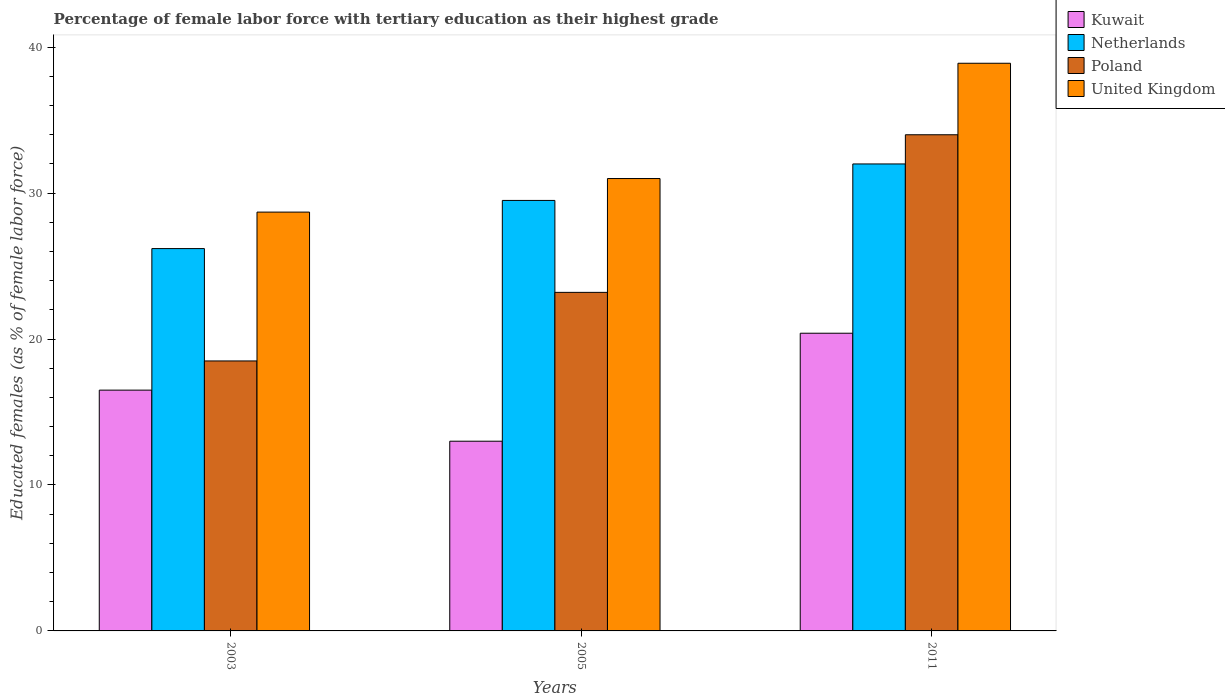How many different coloured bars are there?
Ensure brevity in your answer.  4. How many groups of bars are there?
Provide a short and direct response. 3. Are the number of bars on each tick of the X-axis equal?
Provide a short and direct response. Yes. What is the label of the 1st group of bars from the left?
Keep it short and to the point. 2003. Across all years, what is the maximum percentage of female labor force with tertiary education in United Kingdom?
Make the answer very short. 38.9. Across all years, what is the minimum percentage of female labor force with tertiary education in Netherlands?
Give a very brief answer. 26.2. In which year was the percentage of female labor force with tertiary education in United Kingdom maximum?
Make the answer very short. 2011. In which year was the percentage of female labor force with tertiary education in Poland minimum?
Provide a succinct answer. 2003. What is the total percentage of female labor force with tertiary education in United Kingdom in the graph?
Your response must be concise. 98.6. What is the difference between the percentage of female labor force with tertiary education in United Kingdom in 2003 and that in 2005?
Ensure brevity in your answer.  -2.3. What is the difference between the percentage of female labor force with tertiary education in United Kingdom in 2011 and the percentage of female labor force with tertiary education in Poland in 2005?
Your response must be concise. 15.7. What is the average percentage of female labor force with tertiary education in Netherlands per year?
Your response must be concise. 29.23. In the year 2011, what is the difference between the percentage of female labor force with tertiary education in Netherlands and percentage of female labor force with tertiary education in United Kingdom?
Your answer should be compact. -6.9. What is the ratio of the percentage of female labor force with tertiary education in Poland in 2003 to that in 2005?
Offer a terse response. 0.8. Is the difference between the percentage of female labor force with tertiary education in Netherlands in 2003 and 2005 greater than the difference between the percentage of female labor force with tertiary education in United Kingdom in 2003 and 2005?
Provide a succinct answer. No. What is the difference between the highest and the second highest percentage of female labor force with tertiary education in Kuwait?
Your answer should be compact. 3.9. What is the difference between the highest and the lowest percentage of female labor force with tertiary education in United Kingdom?
Provide a short and direct response. 10.2. Is the sum of the percentage of female labor force with tertiary education in Kuwait in 2005 and 2011 greater than the maximum percentage of female labor force with tertiary education in Netherlands across all years?
Your response must be concise. Yes. What does the 3rd bar from the left in 2011 represents?
Provide a short and direct response. Poland. What does the 1st bar from the right in 2011 represents?
Make the answer very short. United Kingdom. Are all the bars in the graph horizontal?
Ensure brevity in your answer.  No. What is the difference between two consecutive major ticks on the Y-axis?
Give a very brief answer. 10. Are the values on the major ticks of Y-axis written in scientific E-notation?
Provide a succinct answer. No. How many legend labels are there?
Ensure brevity in your answer.  4. How are the legend labels stacked?
Your response must be concise. Vertical. What is the title of the graph?
Provide a succinct answer. Percentage of female labor force with tertiary education as their highest grade. What is the label or title of the Y-axis?
Your response must be concise. Educated females (as % of female labor force). What is the Educated females (as % of female labor force) in Kuwait in 2003?
Your answer should be very brief. 16.5. What is the Educated females (as % of female labor force) of Netherlands in 2003?
Provide a short and direct response. 26.2. What is the Educated females (as % of female labor force) in United Kingdom in 2003?
Make the answer very short. 28.7. What is the Educated females (as % of female labor force) of Netherlands in 2005?
Provide a succinct answer. 29.5. What is the Educated females (as % of female labor force) of Poland in 2005?
Make the answer very short. 23.2. What is the Educated females (as % of female labor force) in United Kingdom in 2005?
Provide a succinct answer. 31. What is the Educated females (as % of female labor force) of Kuwait in 2011?
Your answer should be compact. 20.4. What is the Educated females (as % of female labor force) of Netherlands in 2011?
Provide a short and direct response. 32. What is the Educated females (as % of female labor force) of United Kingdom in 2011?
Make the answer very short. 38.9. Across all years, what is the maximum Educated females (as % of female labor force) in Kuwait?
Your answer should be very brief. 20.4. Across all years, what is the maximum Educated females (as % of female labor force) in Netherlands?
Your answer should be very brief. 32. Across all years, what is the maximum Educated females (as % of female labor force) in Poland?
Make the answer very short. 34. Across all years, what is the maximum Educated females (as % of female labor force) in United Kingdom?
Provide a short and direct response. 38.9. Across all years, what is the minimum Educated females (as % of female labor force) of Netherlands?
Provide a short and direct response. 26.2. Across all years, what is the minimum Educated females (as % of female labor force) of United Kingdom?
Provide a succinct answer. 28.7. What is the total Educated females (as % of female labor force) in Kuwait in the graph?
Offer a terse response. 49.9. What is the total Educated females (as % of female labor force) in Netherlands in the graph?
Your answer should be compact. 87.7. What is the total Educated females (as % of female labor force) of Poland in the graph?
Provide a succinct answer. 75.7. What is the total Educated females (as % of female labor force) of United Kingdom in the graph?
Your answer should be compact. 98.6. What is the difference between the Educated females (as % of female labor force) in Netherlands in 2003 and that in 2005?
Ensure brevity in your answer.  -3.3. What is the difference between the Educated females (as % of female labor force) of Netherlands in 2003 and that in 2011?
Your answer should be compact. -5.8. What is the difference between the Educated females (as % of female labor force) in Poland in 2003 and that in 2011?
Your response must be concise. -15.5. What is the difference between the Educated females (as % of female labor force) in Kuwait in 2005 and that in 2011?
Your answer should be compact. -7.4. What is the difference between the Educated females (as % of female labor force) in Kuwait in 2003 and the Educated females (as % of female labor force) in Poland in 2005?
Offer a terse response. -6.7. What is the difference between the Educated females (as % of female labor force) of Kuwait in 2003 and the Educated females (as % of female labor force) of United Kingdom in 2005?
Your answer should be very brief. -14.5. What is the difference between the Educated females (as % of female labor force) in Poland in 2003 and the Educated females (as % of female labor force) in United Kingdom in 2005?
Keep it short and to the point. -12.5. What is the difference between the Educated females (as % of female labor force) of Kuwait in 2003 and the Educated females (as % of female labor force) of Netherlands in 2011?
Your answer should be compact. -15.5. What is the difference between the Educated females (as % of female labor force) of Kuwait in 2003 and the Educated females (as % of female labor force) of Poland in 2011?
Keep it short and to the point. -17.5. What is the difference between the Educated females (as % of female labor force) of Kuwait in 2003 and the Educated females (as % of female labor force) of United Kingdom in 2011?
Keep it short and to the point. -22.4. What is the difference between the Educated females (as % of female labor force) in Netherlands in 2003 and the Educated females (as % of female labor force) in Poland in 2011?
Give a very brief answer. -7.8. What is the difference between the Educated females (as % of female labor force) in Poland in 2003 and the Educated females (as % of female labor force) in United Kingdom in 2011?
Your answer should be compact. -20.4. What is the difference between the Educated females (as % of female labor force) in Kuwait in 2005 and the Educated females (as % of female labor force) in Poland in 2011?
Offer a very short reply. -21. What is the difference between the Educated females (as % of female labor force) in Kuwait in 2005 and the Educated females (as % of female labor force) in United Kingdom in 2011?
Offer a very short reply. -25.9. What is the difference between the Educated females (as % of female labor force) of Netherlands in 2005 and the Educated females (as % of female labor force) of Poland in 2011?
Offer a terse response. -4.5. What is the difference between the Educated females (as % of female labor force) of Netherlands in 2005 and the Educated females (as % of female labor force) of United Kingdom in 2011?
Your answer should be very brief. -9.4. What is the difference between the Educated females (as % of female labor force) of Poland in 2005 and the Educated females (as % of female labor force) of United Kingdom in 2011?
Your answer should be very brief. -15.7. What is the average Educated females (as % of female labor force) of Kuwait per year?
Give a very brief answer. 16.63. What is the average Educated females (as % of female labor force) in Netherlands per year?
Give a very brief answer. 29.23. What is the average Educated females (as % of female labor force) in Poland per year?
Offer a very short reply. 25.23. What is the average Educated females (as % of female labor force) in United Kingdom per year?
Ensure brevity in your answer.  32.87. In the year 2003, what is the difference between the Educated females (as % of female labor force) in Kuwait and Educated females (as % of female labor force) in Poland?
Provide a short and direct response. -2. In the year 2003, what is the difference between the Educated females (as % of female labor force) in Kuwait and Educated females (as % of female labor force) in United Kingdom?
Your answer should be very brief. -12.2. In the year 2003, what is the difference between the Educated females (as % of female labor force) in Netherlands and Educated females (as % of female labor force) in Poland?
Give a very brief answer. 7.7. In the year 2003, what is the difference between the Educated females (as % of female labor force) in Netherlands and Educated females (as % of female labor force) in United Kingdom?
Your response must be concise. -2.5. In the year 2005, what is the difference between the Educated females (as % of female labor force) in Kuwait and Educated females (as % of female labor force) in Netherlands?
Give a very brief answer. -16.5. In the year 2005, what is the difference between the Educated females (as % of female labor force) in Kuwait and Educated females (as % of female labor force) in Poland?
Your answer should be very brief. -10.2. In the year 2005, what is the difference between the Educated females (as % of female labor force) in Poland and Educated females (as % of female labor force) in United Kingdom?
Provide a succinct answer. -7.8. In the year 2011, what is the difference between the Educated females (as % of female labor force) in Kuwait and Educated females (as % of female labor force) in United Kingdom?
Ensure brevity in your answer.  -18.5. What is the ratio of the Educated females (as % of female labor force) in Kuwait in 2003 to that in 2005?
Provide a short and direct response. 1.27. What is the ratio of the Educated females (as % of female labor force) in Netherlands in 2003 to that in 2005?
Offer a very short reply. 0.89. What is the ratio of the Educated females (as % of female labor force) in Poland in 2003 to that in 2005?
Provide a succinct answer. 0.8. What is the ratio of the Educated females (as % of female labor force) of United Kingdom in 2003 to that in 2005?
Your answer should be very brief. 0.93. What is the ratio of the Educated females (as % of female labor force) in Kuwait in 2003 to that in 2011?
Make the answer very short. 0.81. What is the ratio of the Educated females (as % of female labor force) in Netherlands in 2003 to that in 2011?
Your answer should be compact. 0.82. What is the ratio of the Educated females (as % of female labor force) of Poland in 2003 to that in 2011?
Provide a short and direct response. 0.54. What is the ratio of the Educated females (as % of female labor force) of United Kingdom in 2003 to that in 2011?
Ensure brevity in your answer.  0.74. What is the ratio of the Educated females (as % of female labor force) in Kuwait in 2005 to that in 2011?
Your answer should be very brief. 0.64. What is the ratio of the Educated females (as % of female labor force) in Netherlands in 2005 to that in 2011?
Offer a terse response. 0.92. What is the ratio of the Educated females (as % of female labor force) in Poland in 2005 to that in 2011?
Your response must be concise. 0.68. What is the ratio of the Educated females (as % of female labor force) in United Kingdom in 2005 to that in 2011?
Your answer should be compact. 0.8. What is the difference between the highest and the second highest Educated females (as % of female labor force) in Kuwait?
Your answer should be very brief. 3.9. What is the difference between the highest and the second highest Educated females (as % of female labor force) in Netherlands?
Keep it short and to the point. 2.5. What is the difference between the highest and the second highest Educated females (as % of female labor force) in United Kingdom?
Offer a very short reply. 7.9. What is the difference between the highest and the lowest Educated females (as % of female labor force) of Kuwait?
Ensure brevity in your answer.  7.4. What is the difference between the highest and the lowest Educated females (as % of female labor force) in United Kingdom?
Provide a succinct answer. 10.2. 